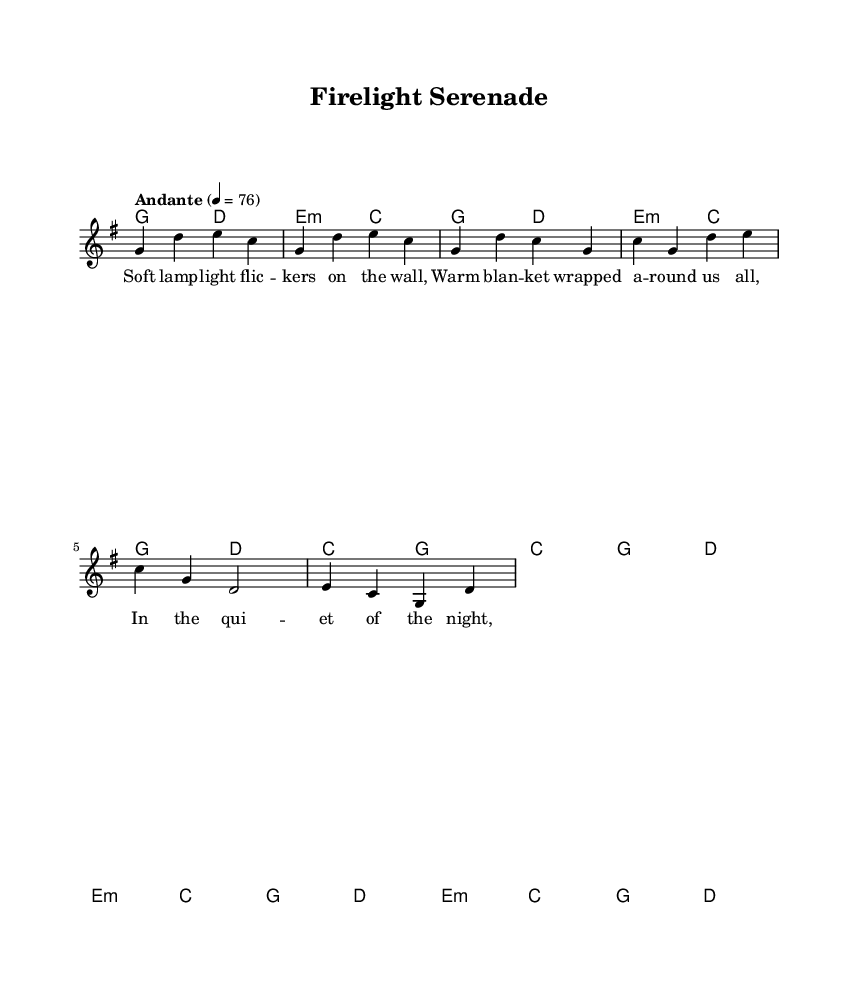What is the key signature of this music? The key signature is G major, which has one sharp (F#). This can be identified by looking at the beginning of the staff where the key signature is notated.
Answer: G major What is the time signature of this music? The time signature is 4/4, indicated at the beginning of the music. This shows that there are four beats in each measure and a quarter note receives one beat.
Answer: 4/4 What is the tempo marking of this song? The tempo marking is "Andante," which suggests a moderately slow tempo. This is indicated in the tempo section of the score.
Answer: Andante How many measures are there in the chorus? The chorus consists of four measures, which can be counted by looking at the section labeled "Chorus" and counting the bars.
Answer: 4 What is the first chord of the piece? The first chord in the piece is G major, located at the beginning of the chord section under the introduction. This is deduced from the chord mode notation which lists the chords played.
Answer: G Which line of the lyrics corresponds to the chorus? The line "In the quiet of the night, Everything feels just right," corresponds to the chorus, as indicated under the section labeled "chorus" in the lyric mode.
Answer: In the quiet of the night, Everything feels just right What is the last chord before the bridge section? The last chord before the bridge section is D major, which can be found in the harmonies section right before the bridge notation begins.
Answer: D 